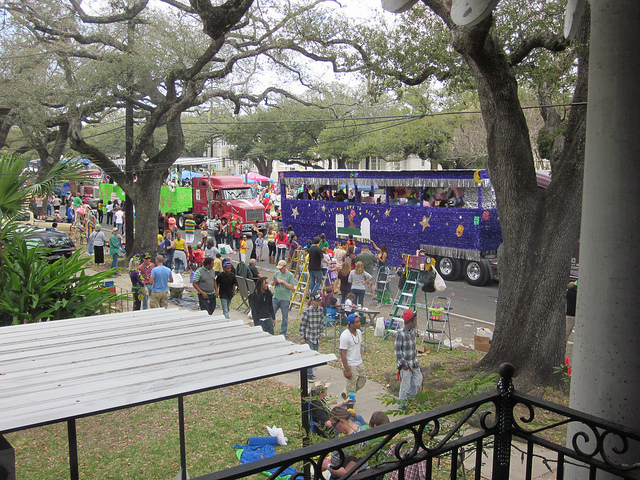<image>What type are birds are pictured? There are no birds in the image. What type are birds are pictured? I am not sure what type of birds are pictured. It is possible that there are no birds or pigeons. However, a woodpecker is also seen. 